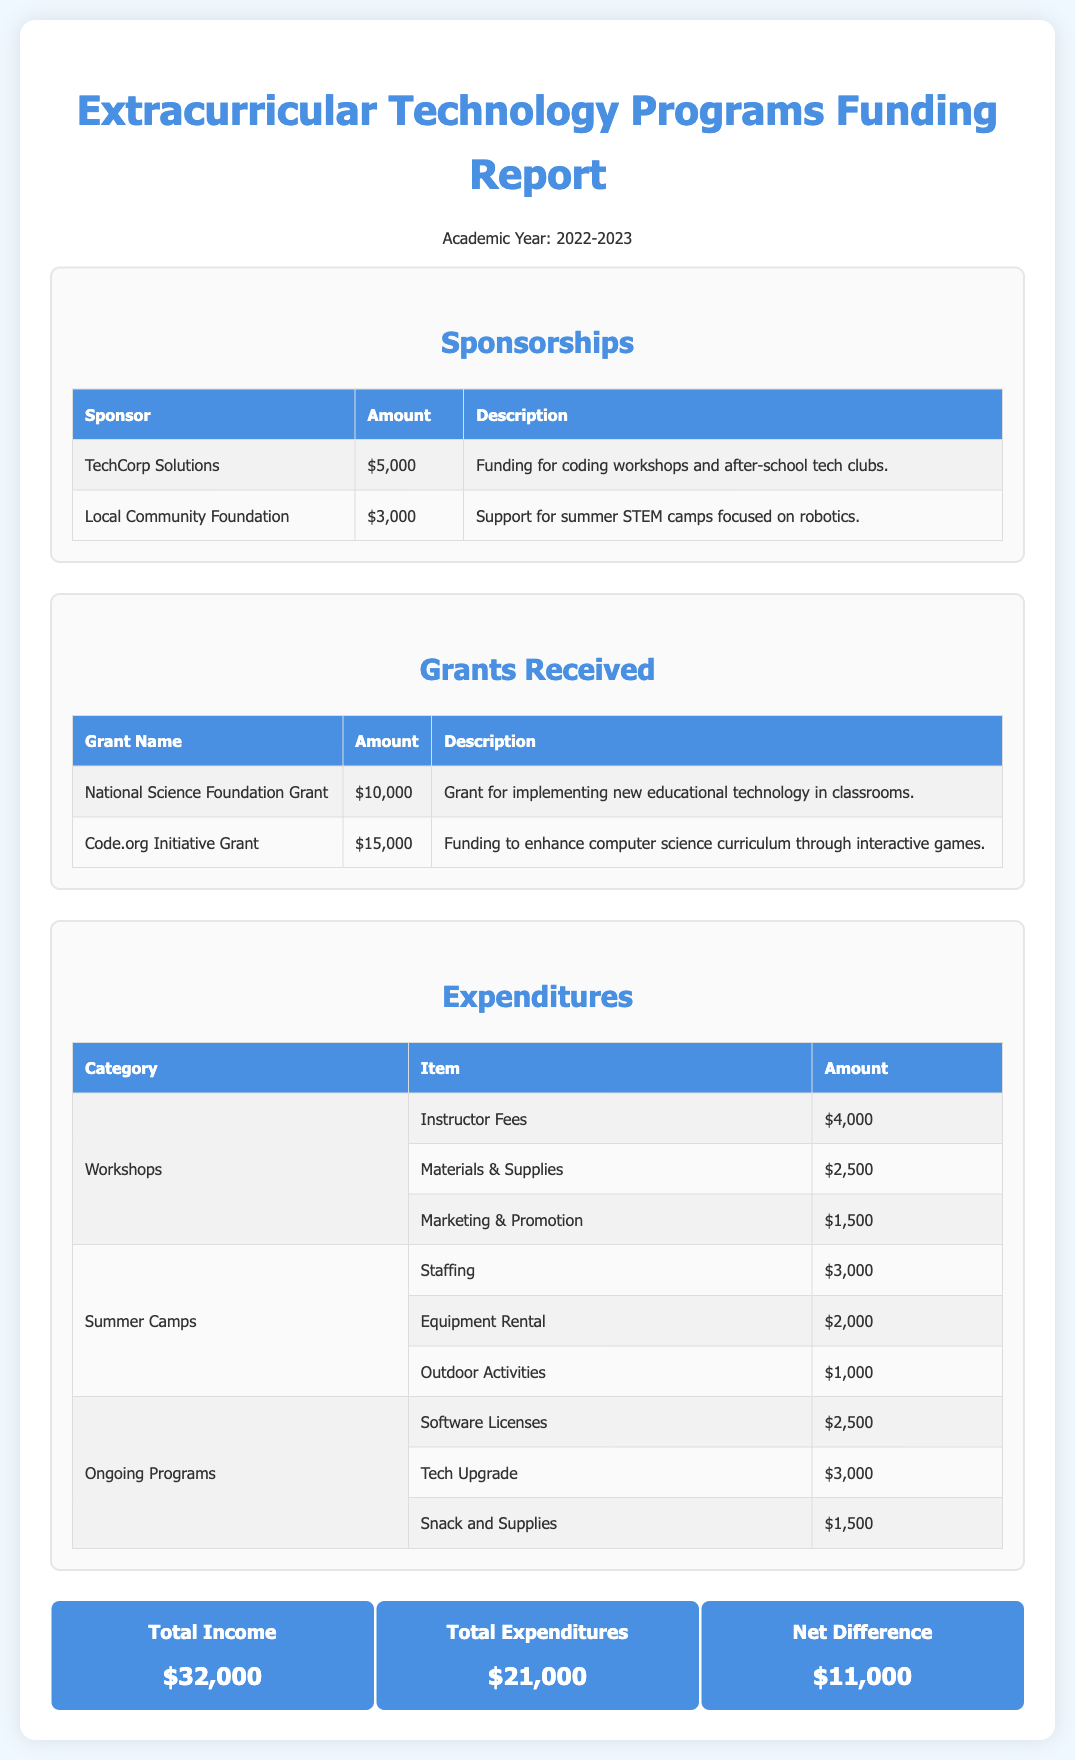What is the total amount received from sponsors? The total sponsorship amount is calculated by adding the amounts from all sponsors listed in the document: $5,000 + $3,000 = $8,000.
Answer: $8,000 How much was received from the Code.org Initiative Grant? The document specifies that the Code.org Initiative Grant amounted to $15,000.
Answer: $15,000 What was the total expenditure on Workshops? The document details the expenditures on Workshops, summing up to: $4,000 (Instructor Fees) + $2,500 (Materials & Supplies) + $1,500 (Marketing & Promotion) = $8,000.
Answer: $8,000 Which organization provided funding for summer STEM camps? The Local Community Foundation is mentioned as the sponsor for summer STEM camps.
Answer: Local Community Foundation What is the net difference between total income and total expenditures? The net difference is calculated by subtracting total expenditures from total income: $32,000 (Total Income) - $21,000 (Total Expenditures) = $11,000.
Answer: $11,000 How much was allocated for Equipment Rental in Summer Camps? The amount for Equipment Rental in Summer Camps is indicated as $2,000 in the expenditures section.
Answer: $2,000 What is the description provided for the funding from TechCorp Solutions? The document describes the funding from TechCorp Solutions as support for coding workshops and after-school tech clubs.
Answer: Funding for coding workshops and after-school tech clubs How many grant sources are listed in the document? The document lists two grant sources: National Science Foundation Grant and Code.org Initiative Grant.
Answer: 2 What was the total amount earmarked for Snack and Supplies in Ongoing Programs? The expenditure amount for Snack and Supplies in Ongoing Programs is $1,500 as stated in the document.
Answer: $1,500 What does the summary highlight about total income? The summary states that the total income for the extracurricular technology programs is $32,000.
Answer: $32,000 